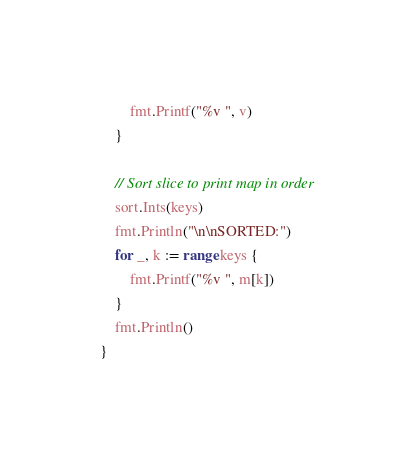Convert code to text. <code><loc_0><loc_0><loc_500><loc_500><_Go_>		fmt.Printf("%v ", v)
	}

	// Sort slice to print map in order
	sort.Ints(keys)
	fmt.Println("\n\nSORTED:")
	for _, k := range keys {
		fmt.Printf("%v ", m[k])
	}
	fmt.Println()
}
</code> 